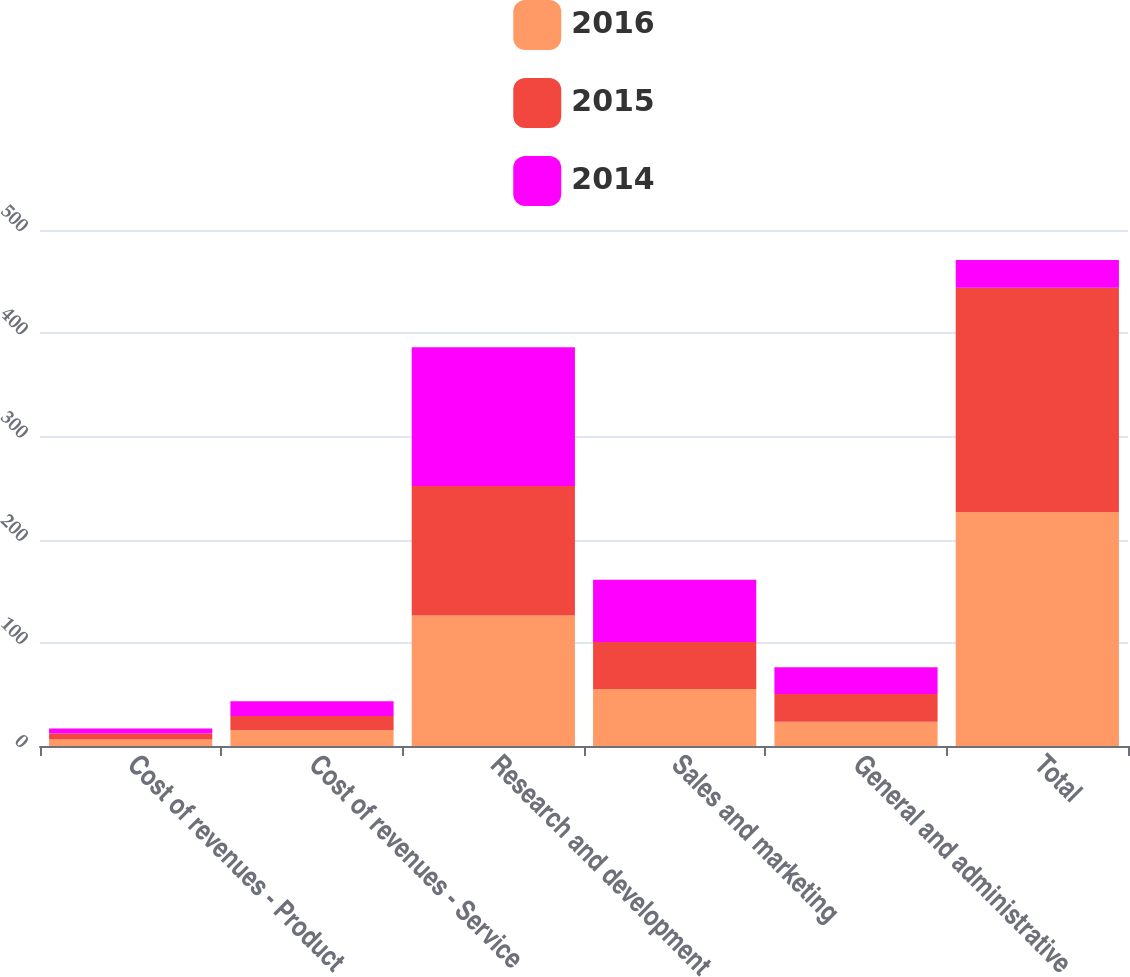Convert chart to OTSL. <chart><loc_0><loc_0><loc_500><loc_500><stacked_bar_chart><ecel><fcel>Cost of revenues - Product<fcel>Cost of revenues - Service<fcel>Research and development<fcel>Sales and marketing<fcel>General and administrative<fcel>Total<nl><fcel>2016<fcel>6.4<fcel>15.3<fcel>126.5<fcel>55.2<fcel>23.4<fcel>226.8<nl><fcel>2015<fcel>5.6<fcel>13.8<fcel>125.4<fcel>45.6<fcel>26.9<fcel>217.3<nl><fcel>2014<fcel>5<fcel>14.2<fcel>134.5<fcel>60.2<fcel>26.1<fcel>26.9<nl></chart> 